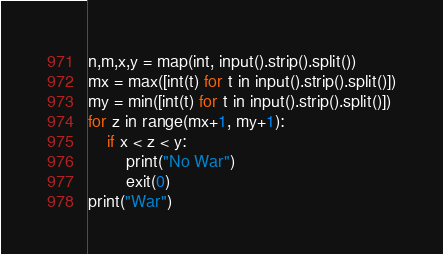Convert code to text. <code><loc_0><loc_0><loc_500><loc_500><_Python_>n,m,x,y = map(int, input().strip().split())
mx = max([int(t) for t in input().strip().split()])
my = min([int(t) for t in input().strip().split()])
for z in range(mx+1, my+1):
    if x < z < y:
        print("No War")
        exit(0)
print("War")</code> 